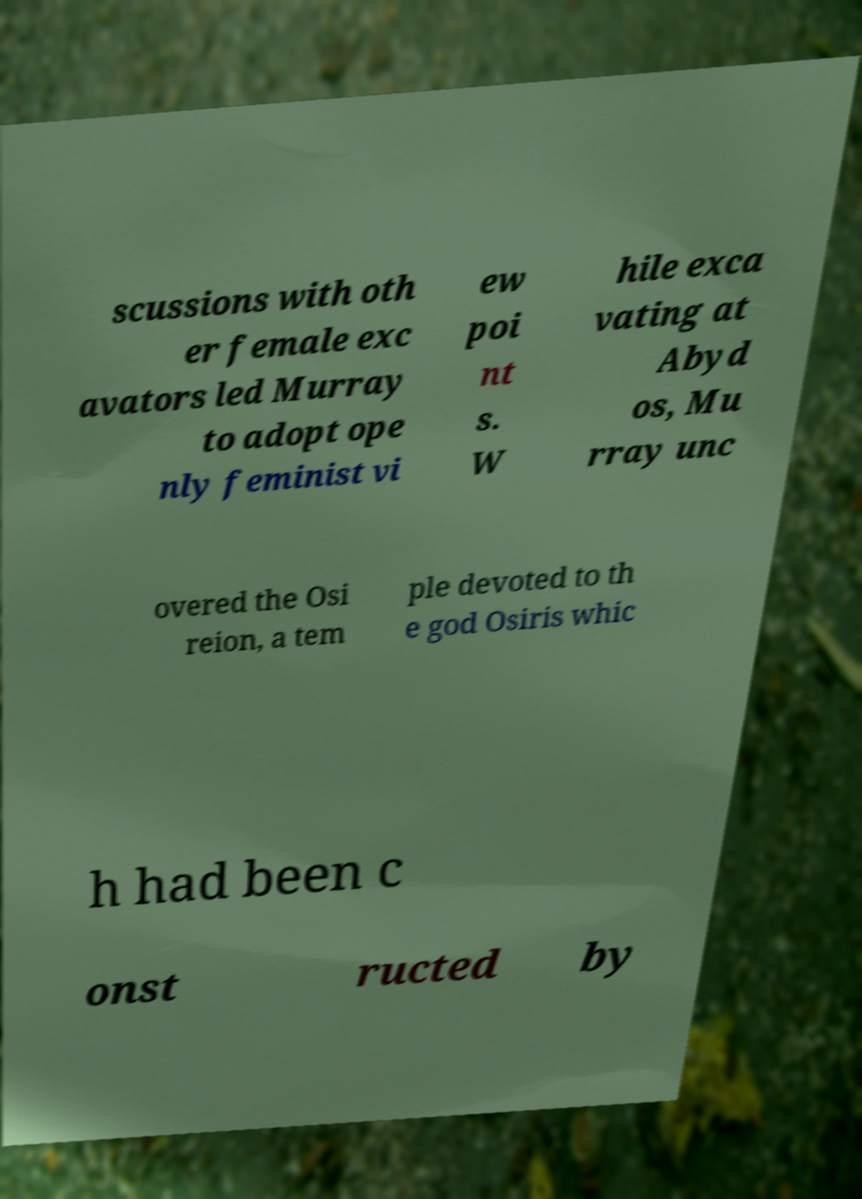Could you extract and type out the text from this image? scussions with oth er female exc avators led Murray to adopt ope nly feminist vi ew poi nt s. W hile exca vating at Abyd os, Mu rray unc overed the Osi reion, a tem ple devoted to th e god Osiris whic h had been c onst ructed by 